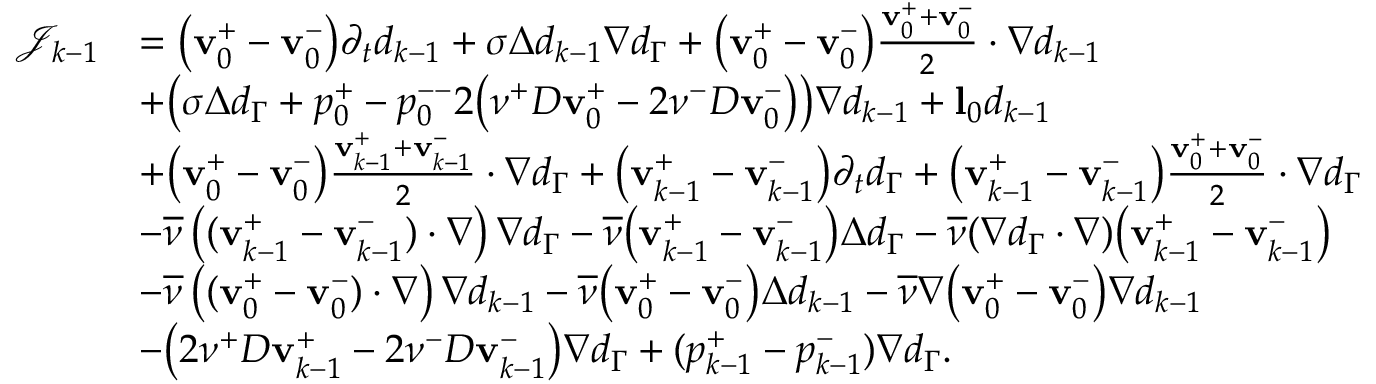<formula> <loc_0><loc_0><loc_500><loc_500>\begin{array} { r l } { \mathcal { J } _ { k - 1 } } & { = \left ( v _ { 0 } ^ { + } - v _ { 0 } ^ { - } \right ) \partial _ { t } d _ { k - 1 } + \sigma \Delta d _ { k - 1 } \nabla d _ { \Gamma } + \left ( v _ { 0 } ^ { + } - v _ { 0 } ^ { - } \right ) \frac { v _ { 0 } ^ { + } + v _ { 0 } ^ { - } } { 2 } \cdot \nabla d _ { k - 1 } } \\ & { + \left ( \sigma \Delta d _ { \Gamma } + p _ { 0 } ^ { + } - p _ { 0 } ^ { - - } 2 \left ( \nu ^ { + } D v _ { 0 } ^ { + } - 2 \nu ^ { - } D v _ { 0 } ^ { - } \right ) \right ) \nabla d _ { k - 1 } + l _ { 0 } d _ { k - 1 } } \\ & { + \left ( v _ { 0 } ^ { + } - v _ { 0 } ^ { - } \right ) \frac { v _ { k - 1 } ^ { + } + v _ { k - 1 } ^ { - } } { 2 } \cdot \nabla d _ { \Gamma } + \left ( v _ { k - 1 } ^ { + } - v _ { k - 1 } ^ { - } \right ) \partial _ { t } d _ { \Gamma } + \left ( v _ { k - 1 } ^ { + } - v _ { k - 1 } ^ { - } \right ) \frac { v _ { 0 } ^ { + } + v _ { 0 } ^ { - } } { 2 } \cdot \nabla d _ { \Gamma } } \\ & { - \overline { \nu } \left ( ( v _ { k - 1 } ^ { + } - v _ { k - 1 } ^ { - } ) \cdot \nabla \right ) \nabla d _ { \Gamma } - \overline { \nu } \left ( v _ { k - 1 } ^ { + } - v _ { k - 1 } ^ { - } \right ) \Delta d _ { \Gamma } - \overline { \nu } ( \nabla d _ { \Gamma } \cdot \nabla ) \left ( v _ { k - 1 } ^ { + } - v _ { k - 1 } ^ { - } \right ) } \\ & { { - \overline { \nu } \left ( ( v _ { 0 } ^ { + } - v _ { 0 } ^ { - } ) \cdot \nabla \right ) \nabla d _ { k - 1 } - \overline { \nu } \left ( v _ { 0 } ^ { + } - v _ { 0 } ^ { - } \right ) \Delta d _ { k - 1 } - \overline { \nu } \nabla \left ( v _ { 0 } ^ { + } - v _ { 0 } ^ { - } \right ) \nabla d _ { k - 1 } } } \\ & { - \left ( 2 \nu ^ { + } D v _ { k - 1 } ^ { + } - 2 \nu ^ { - } D v _ { k - 1 } ^ { - } \right ) \nabla d _ { \Gamma } + ( p _ { k - 1 } ^ { + } - p _ { k - 1 } ^ { - } ) \nabla d _ { \Gamma } . } \end{array}</formula> 